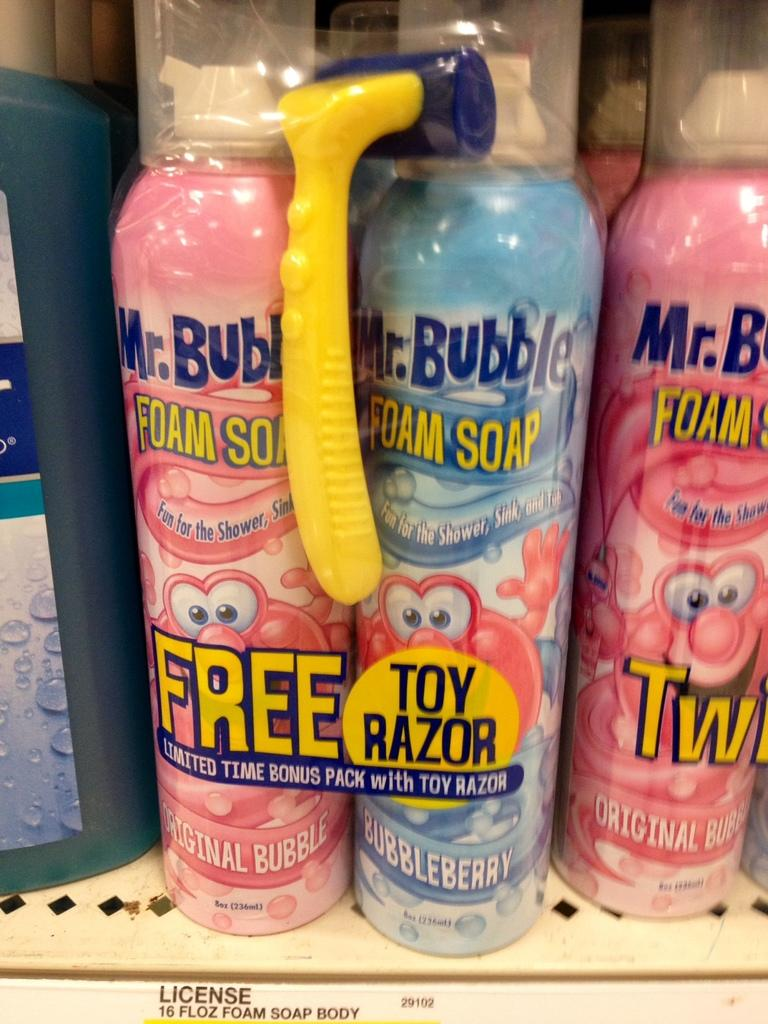Provide a one-sentence caption for the provided image. A store display for pink and blue Mr. Bubble Foam Soap. 